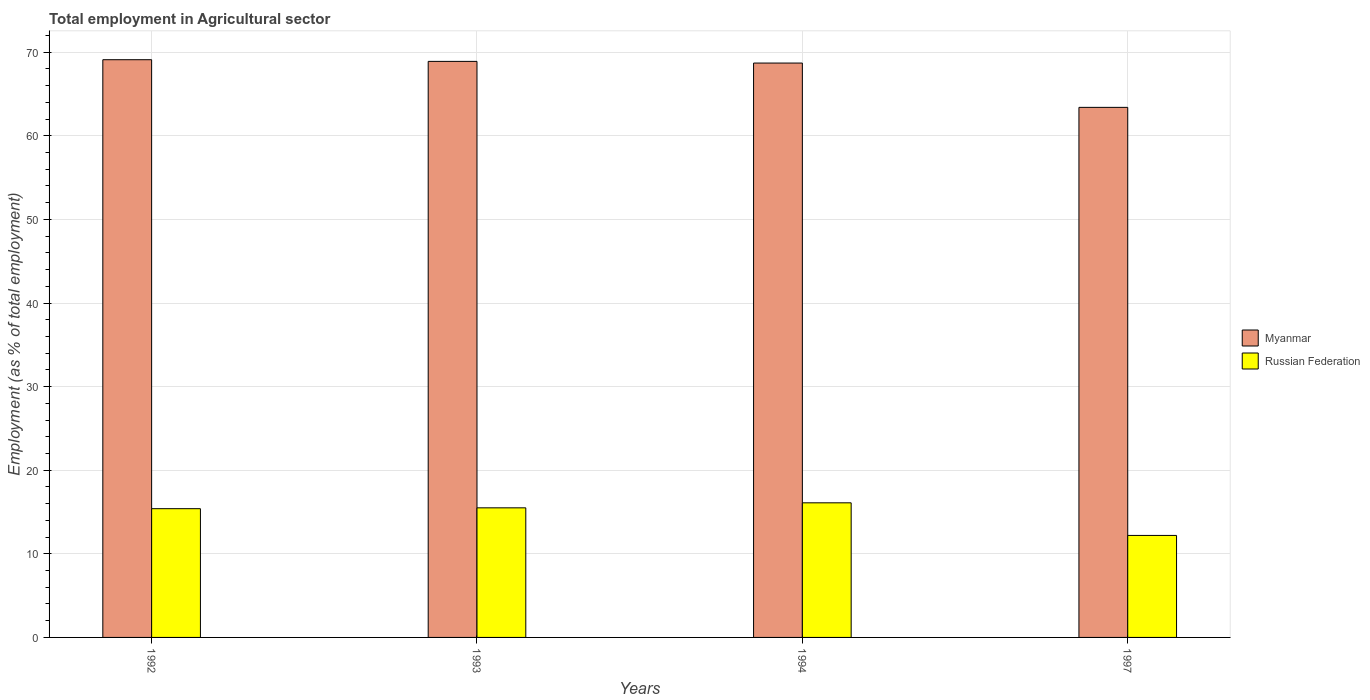Are the number of bars on each tick of the X-axis equal?
Offer a terse response. Yes. How many bars are there on the 3rd tick from the left?
Provide a succinct answer. 2. How many bars are there on the 4th tick from the right?
Make the answer very short. 2. What is the employment in agricultural sector in Myanmar in 1993?
Offer a very short reply. 68.9. Across all years, what is the maximum employment in agricultural sector in Russian Federation?
Your answer should be very brief. 16.1. Across all years, what is the minimum employment in agricultural sector in Myanmar?
Your response must be concise. 63.4. In which year was the employment in agricultural sector in Myanmar maximum?
Make the answer very short. 1992. In which year was the employment in agricultural sector in Russian Federation minimum?
Your response must be concise. 1997. What is the total employment in agricultural sector in Russian Federation in the graph?
Keep it short and to the point. 59.2. What is the difference between the employment in agricultural sector in Russian Federation in 1993 and that in 1994?
Offer a terse response. -0.6. What is the difference between the employment in agricultural sector in Russian Federation in 1993 and the employment in agricultural sector in Myanmar in 1994?
Your response must be concise. -53.2. What is the average employment in agricultural sector in Russian Federation per year?
Ensure brevity in your answer.  14.8. In the year 1994, what is the difference between the employment in agricultural sector in Russian Federation and employment in agricultural sector in Myanmar?
Provide a short and direct response. -52.6. What is the ratio of the employment in agricultural sector in Russian Federation in 1992 to that in 1994?
Offer a very short reply. 0.96. What is the difference between the highest and the second highest employment in agricultural sector in Russian Federation?
Your answer should be very brief. 0.6. What is the difference between the highest and the lowest employment in agricultural sector in Myanmar?
Make the answer very short. 5.7. In how many years, is the employment in agricultural sector in Myanmar greater than the average employment in agricultural sector in Myanmar taken over all years?
Make the answer very short. 3. Is the sum of the employment in agricultural sector in Russian Federation in 1993 and 1994 greater than the maximum employment in agricultural sector in Myanmar across all years?
Your response must be concise. No. What does the 1st bar from the left in 1997 represents?
Make the answer very short. Myanmar. What does the 1st bar from the right in 1994 represents?
Make the answer very short. Russian Federation. Are the values on the major ticks of Y-axis written in scientific E-notation?
Provide a succinct answer. No. Does the graph contain any zero values?
Give a very brief answer. No. Does the graph contain grids?
Your answer should be compact. Yes. How many legend labels are there?
Your answer should be very brief. 2. How are the legend labels stacked?
Offer a terse response. Vertical. What is the title of the graph?
Your response must be concise. Total employment in Agricultural sector. Does "Korea (Democratic)" appear as one of the legend labels in the graph?
Your response must be concise. No. What is the label or title of the X-axis?
Offer a terse response. Years. What is the label or title of the Y-axis?
Your answer should be compact. Employment (as % of total employment). What is the Employment (as % of total employment) in Myanmar in 1992?
Your answer should be compact. 69.1. What is the Employment (as % of total employment) in Russian Federation in 1992?
Keep it short and to the point. 15.4. What is the Employment (as % of total employment) in Myanmar in 1993?
Offer a very short reply. 68.9. What is the Employment (as % of total employment) of Myanmar in 1994?
Keep it short and to the point. 68.7. What is the Employment (as % of total employment) of Russian Federation in 1994?
Offer a terse response. 16.1. What is the Employment (as % of total employment) in Myanmar in 1997?
Ensure brevity in your answer.  63.4. What is the Employment (as % of total employment) in Russian Federation in 1997?
Provide a succinct answer. 12.2. Across all years, what is the maximum Employment (as % of total employment) in Myanmar?
Ensure brevity in your answer.  69.1. Across all years, what is the maximum Employment (as % of total employment) in Russian Federation?
Your response must be concise. 16.1. Across all years, what is the minimum Employment (as % of total employment) in Myanmar?
Keep it short and to the point. 63.4. Across all years, what is the minimum Employment (as % of total employment) in Russian Federation?
Your answer should be very brief. 12.2. What is the total Employment (as % of total employment) of Myanmar in the graph?
Keep it short and to the point. 270.1. What is the total Employment (as % of total employment) of Russian Federation in the graph?
Your answer should be compact. 59.2. What is the difference between the Employment (as % of total employment) in Myanmar in 1992 and that in 1993?
Provide a short and direct response. 0.2. What is the difference between the Employment (as % of total employment) in Russian Federation in 1992 and that in 1993?
Ensure brevity in your answer.  -0.1. What is the difference between the Employment (as % of total employment) in Myanmar in 1992 and that in 1994?
Your answer should be very brief. 0.4. What is the difference between the Employment (as % of total employment) in Myanmar in 1992 and that in 1997?
Give a very brief answer. 5.7. What is the difference between the Employment (as % of total employment) in Myanmar in 1993 and that in 1994?
Your answer should be compact. 0.2. What is the difference between the Employment (as % of total employment) in Myanmar in 1993 and that in 1997?
Keep it short and to the point. 5.5. What is the difference between the Employment (as % of total employment) of Myanmar in 1992 and the Employment (as % of total employment) of Russian Federation in 1993?
Make the answer very short. 53.6. What is the difference between the Employment (as % of total employment) of Myanmar in 1992 and the Employment (as % of total employment) of Russian Federation in 1994?
Give a very brief answer. 53. What is the difference between the Employment (as % of total employment) of Myanmar in 1992 and the Employment (as % of total employment) of Russian Federation in 1997?
Ensure brevity in your answer.  56.9. What is the difference between the Employment (as % of total employment) of Myanmar in 1993 and the Employment (as % of total employment) of Russian Federation in 1994?
Ensure brevity in your answer.  52.8. What is the difference between the Employment (as % of total employment) of Myanmar in 1993 and the Employment (as % of total employment) of Russian Federation in 1997?
Provide a short and direct response. 56.7. What is the difference between the Employment (as % of total employment) in Myanmar in 1994 and the Employment (as % of total employment) in Russian Federation in 1997?
Provide a succinct answer. 56.5. What is the average Employment (as % of total employment) of Myanmar per year?
Offer a very short reply. 67.53. What is the average Employment (as % of total employment) in Russian Federation per year?
Your answer should be compact. 14.8. In the year 1992, what is the difference between the Employment (as % of total employment) in Myanmar and Employment (as % of total employment) in Russian Federation?
Your answer should be compact. 53.7. In the year 1993, what is the difference between the Employment (as % of total employment) in Myanmar and Employment (as % of total employment) in Russian Federation?
Give a very brief answer. 53.4. In the year 1994, what is the difference between the Employment (as % of total employment) in Myanmar and Employment (as % of total employment) in Russian Federation?
Your answer should be very brief. 52.6. In the year 1997, what is the difference between the Employment (as % of total employment) of Myanmar and Employment (as % of total employment) of Russian Federation?
Provide a succinct answer. 51.2. What is the ratio of the Employment (as % of total employment) of Myanmar in 1992 to that in 1993?
Provide a short and direct response. 1. What is the ratio of the Employment (as % of total employment) in Russian Federation in 1992 to that in 1993?
Offer a terse response. 0.99. What is the ratio of the Employment (as % of total employment) of Russian Federation in 1992 to that in 1994?
Provide a succinct answer. 0.96. What is the ratio of the Employment (as % of total employment) in Myanmar in 1992 to that in 1997?
Keep it short and to the point. 1.09. What is the ratio of the Employment (as % of total employment) of Russian Federation in 1992 to that in 1997?
Provide a short and direct response. 1.26. What is the ratio of the Employment (as % of total employment) in Russian Federation in 1993 to that in 1994?
Ensure brevity in your answer.  0.96. What is the ratio of the Employment (as % of total employment) of Myanmar in 1993 to that in 1997?
Provide a succinct answer. 1.09. What is the ratio of the Employment (as % of total employment) in Russian Federation in 1993 to that in 1997?
Give a very brief answer. 1.27. What is the ratio of the Employment (as % of total employment) in Myanmar in 1994 to that in 1997?
Your answer should be compact. 1.08. What is the ratio of the Employment (as % of total employment) of Russian Federation in 1994 to that in 1997?
Your response must be concise. 1.32. What is the difference between the highest and the second highest Employment (as % of total employment) in Myanmar?
Your answer should be very brief. 0.2. 